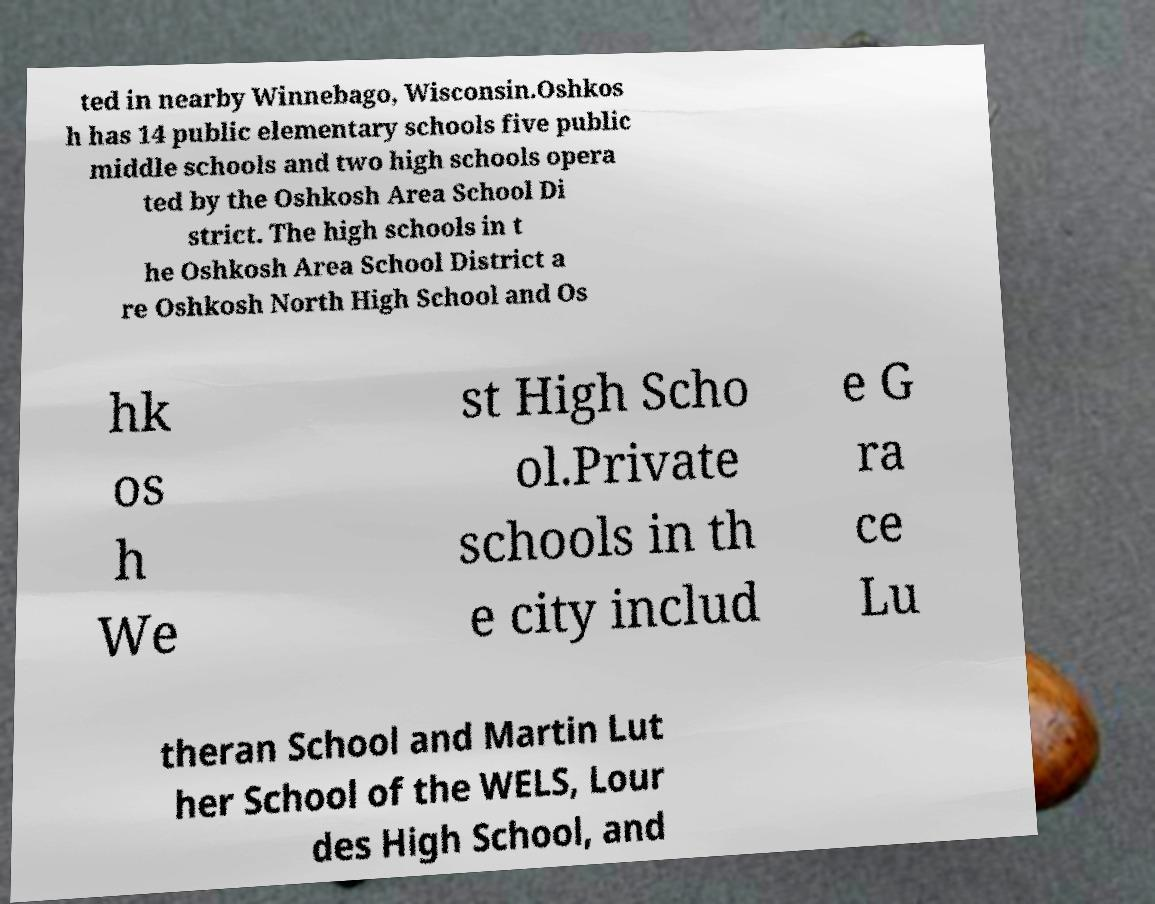What messages or text are displayed in this image? I need them in a readable, typed format. ted in nearby Winnebago, Wisconsin.Oshkos h has 14 public elementary schools five public middle schools and two high schools opera ted by the Oshkosh Area School Di strict. The high schools in t he Oshkosh Area School District a re Oshkosh North High School and Os hk os h We st High Scho ol.Private schools in th e city includ e G ra ce Lu theran School and Martin Lut her School of the WELS, Lour des High School, and 